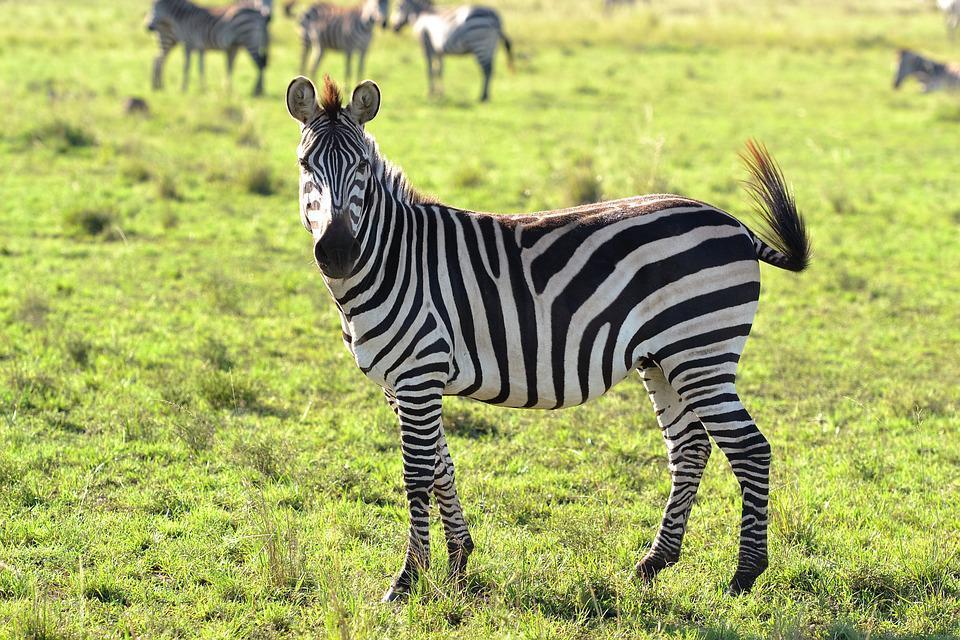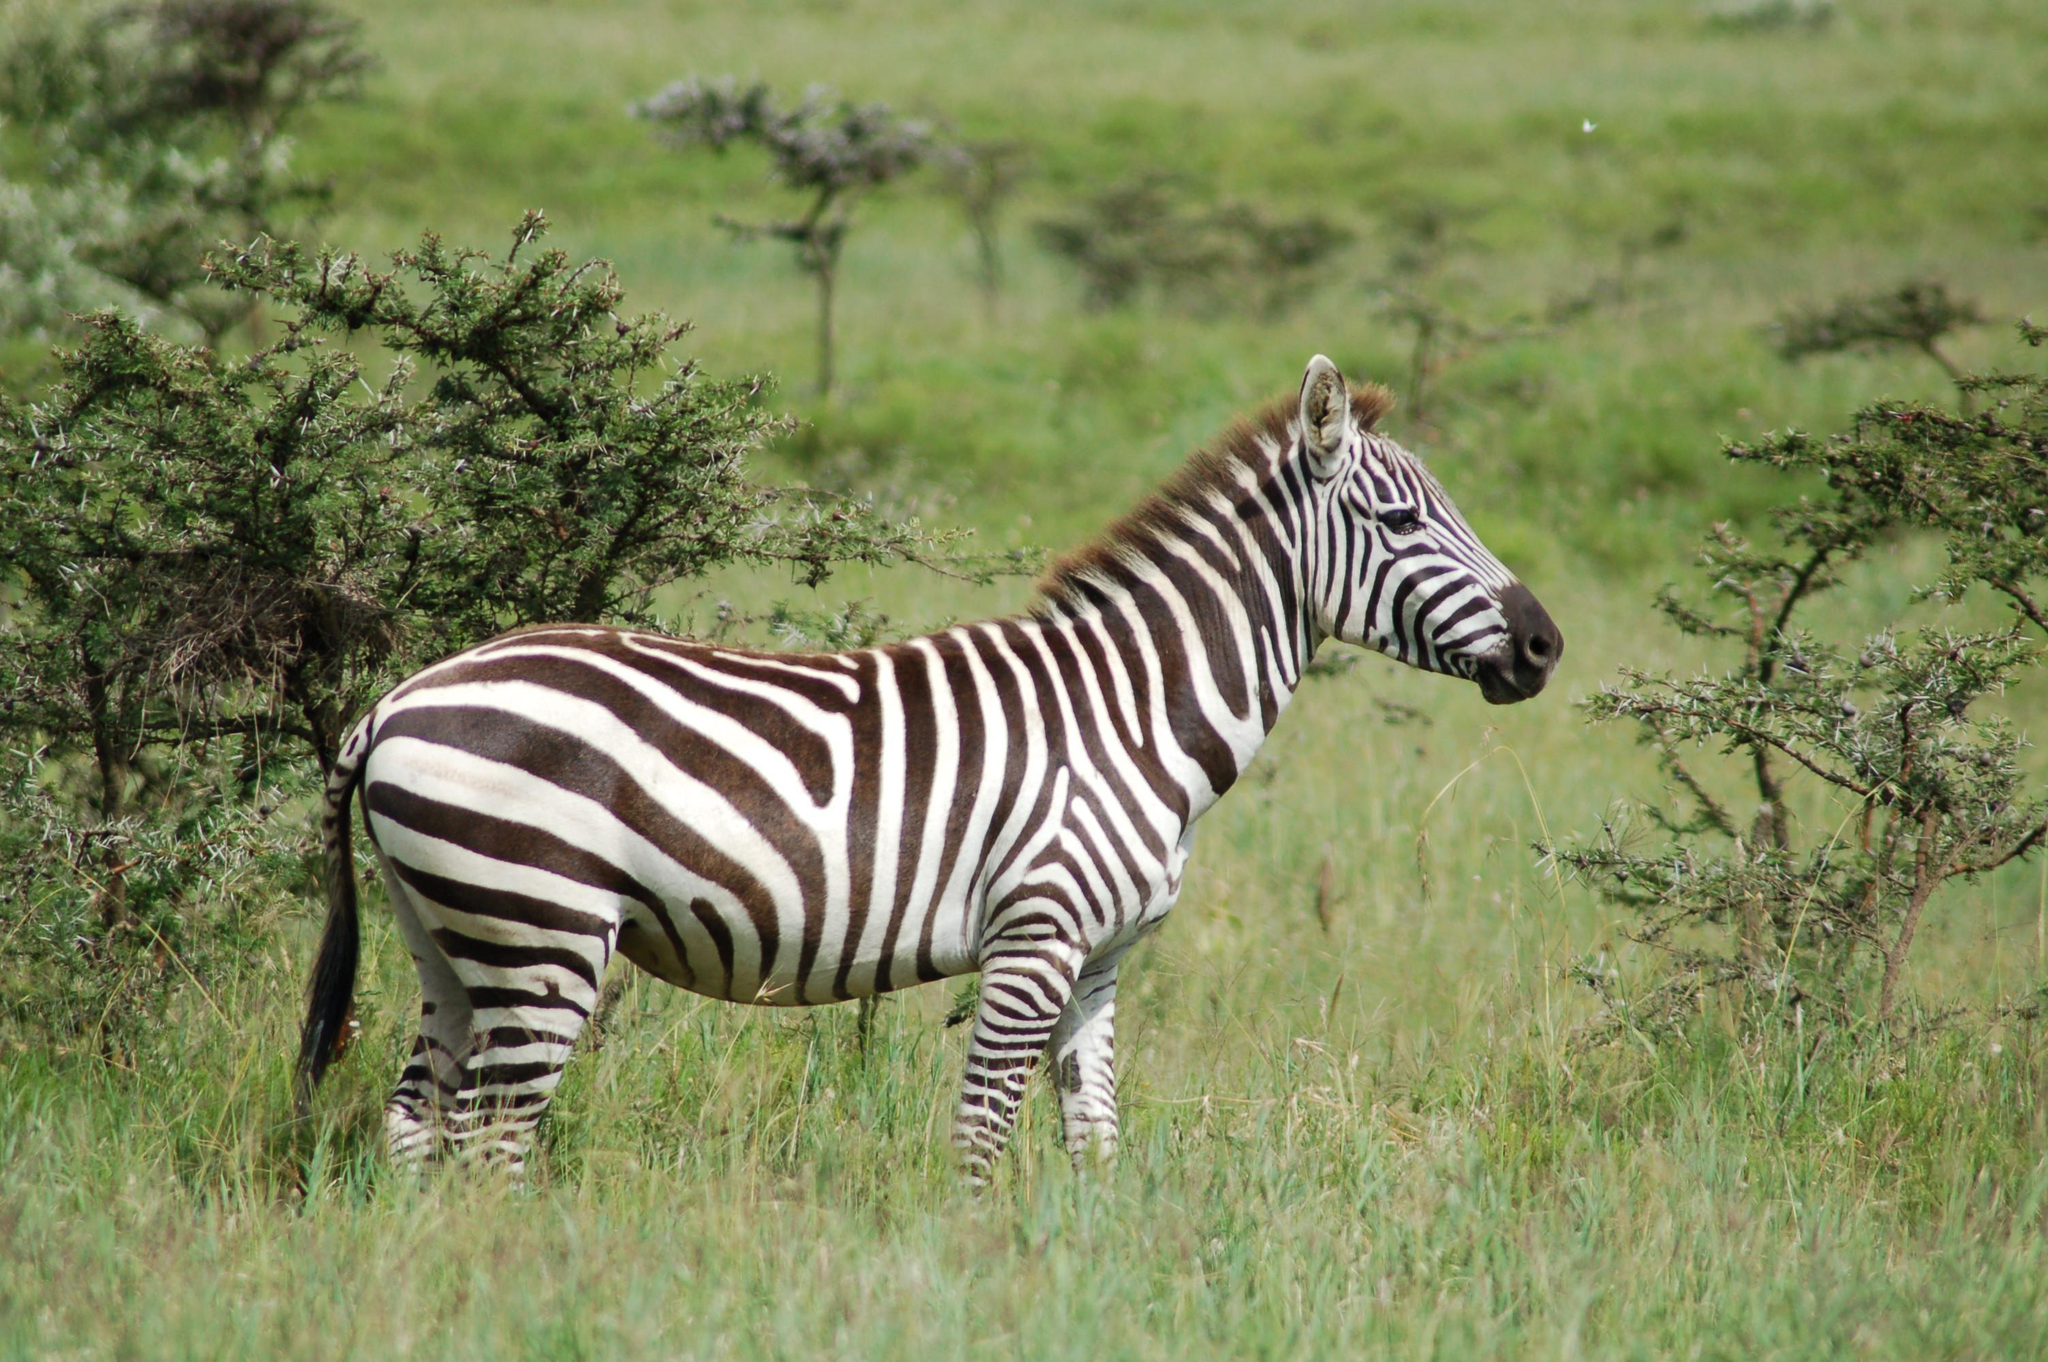The first image is the image on the left, the second image is the image on the right. Evaluate the accuracy of this statement regarding the images: "A zebra has its head down eating the very short green grass.". Is it true? Answer yes or no. No. The first image is the image on the left, the second image is the image on the right. Analyze the images presented: Is the assertion "In one image a lone zebra is standing and grazing in the grass." valid? Answer yes or no. No. 